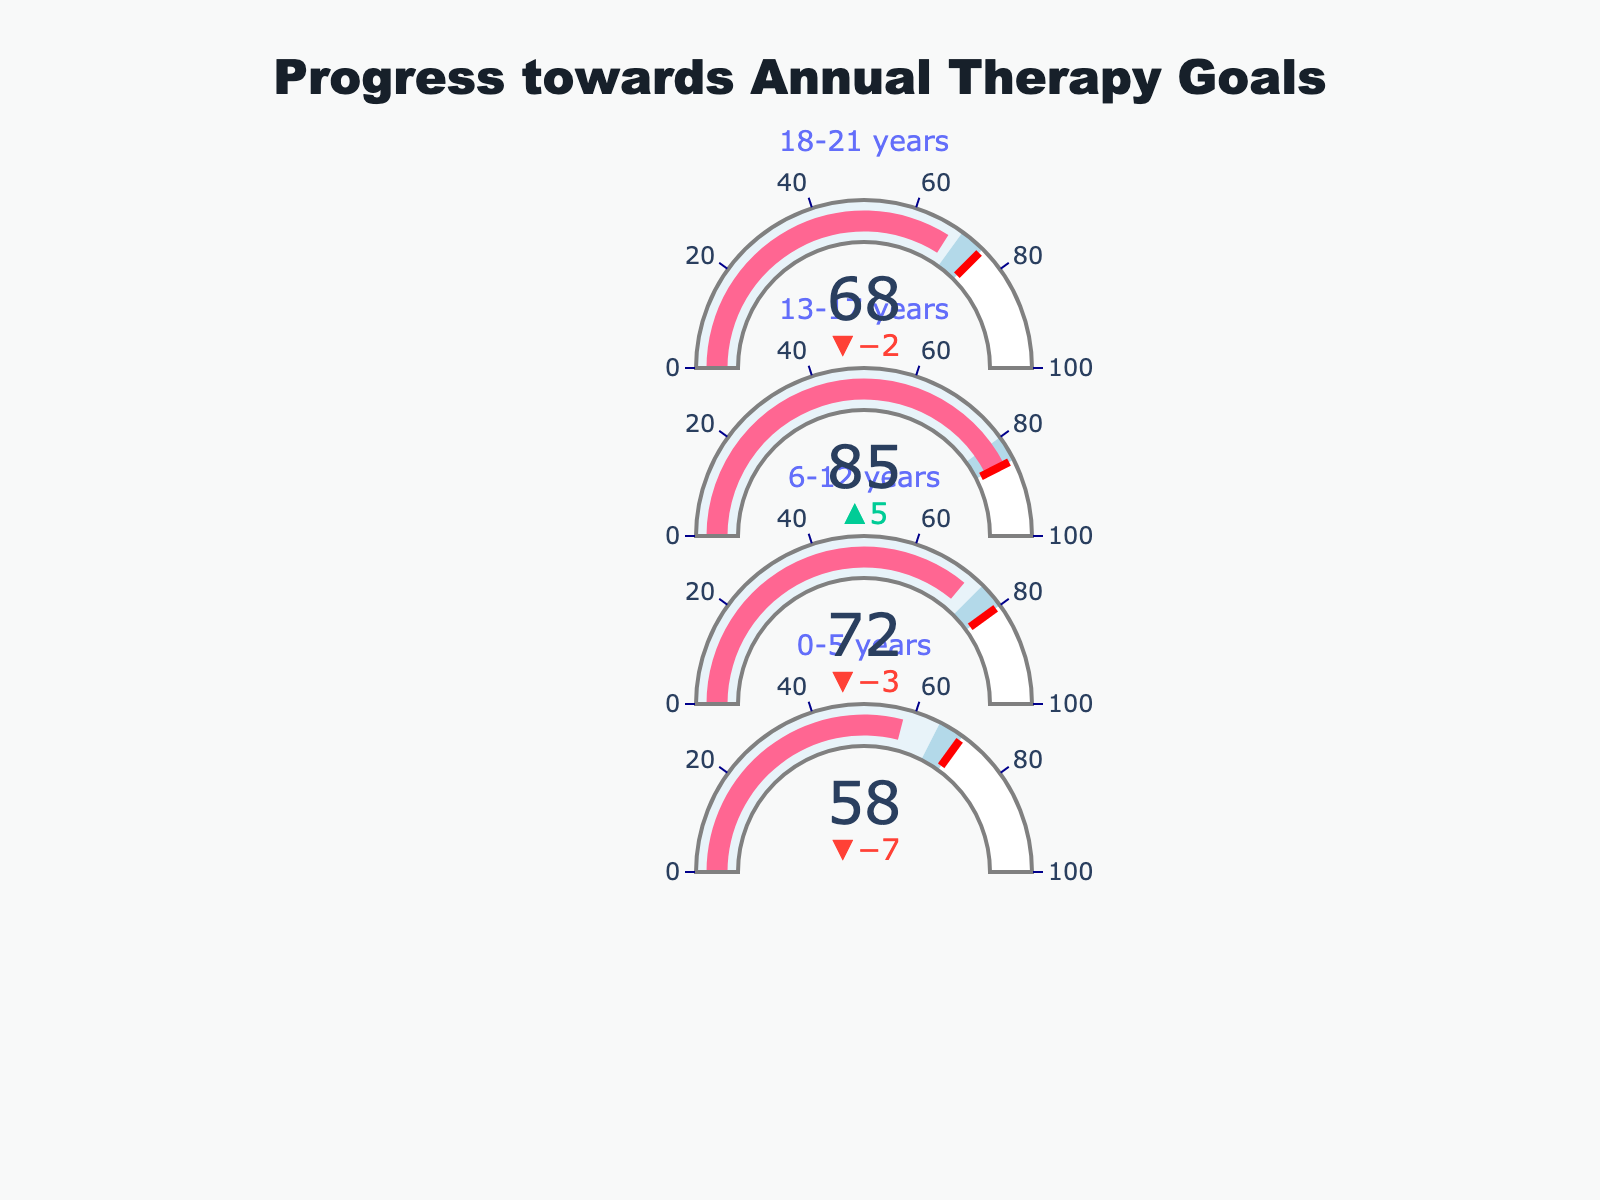What is the title of the chart? The title of the chart is displayed at the top and is meant to summarize the main topic of the figure. The title is "*Progress towards Annual Therapy Goals*".
Answer: Progress towards Annual Therapy Goals Which age group has the highest actual progress? To determine which age group has the highest actual progress, we look for the highest value in the 'Actual Progress' column. The age group 13-17 years has an actual progress of 85, which is the highest among all groups.
Answer: 13-17 years How many age groups have met or exceeded their target progress? To answer this, we need to compare the 'Actual Progress' with the 'Target' for each age group. The age group 13-17 years surpassed their target (85 vs. 85). Other age groups did not meet their targets.
Answer: 1 What is the difference between the goal and actual progress for the 0-5 years age group? To find the difference, we subtract the 'Actual Progress' from the 'Goal' for the 0-5 years age group (65 - 58).
Answer: 7 Which age group is closest to its target progress? To answer, compare the difference between the 'Actual Progress' and 'Target' for each age group. The smallest difference is for the 13-17 years group where actual progress is equal to the target (0 difference).
Answer: 13-17 years How many age groups have actual progress values that are below their respective goals? Compare the 'Actual Progress' values with the 'Goal' values for each age group. The 0-5 years, 6-12 years, and 18-21 years groups all have actual progress values below their goals.
Answer: 3 Which age group has the largest gap between their goal and target? To find this, calculate the difference between the 'Goal' and 'Target' for each age group. The largest gap exists for the 0-5 years group (70 - 65 = 5).
Answer: 0-5 years What is the sum of goals for all age groups? Sum the 'Goal' values for all age groups: (65 + 75 + 80 + 70). The sum is 290.
Answer: 290 What is the cumulative actual progress for all age groups? Add up the 'Actual Progress' values for all age groups: (58 + 72 + 85 + 68). The cumulative actual progress is 283.
Answer: 283 